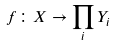Convert formula to latex. <formula><loc_0><loc_0><loc_500><loc_500>f \colon X \rightarrow \prod _ { i } Y _ { i }</formula> 